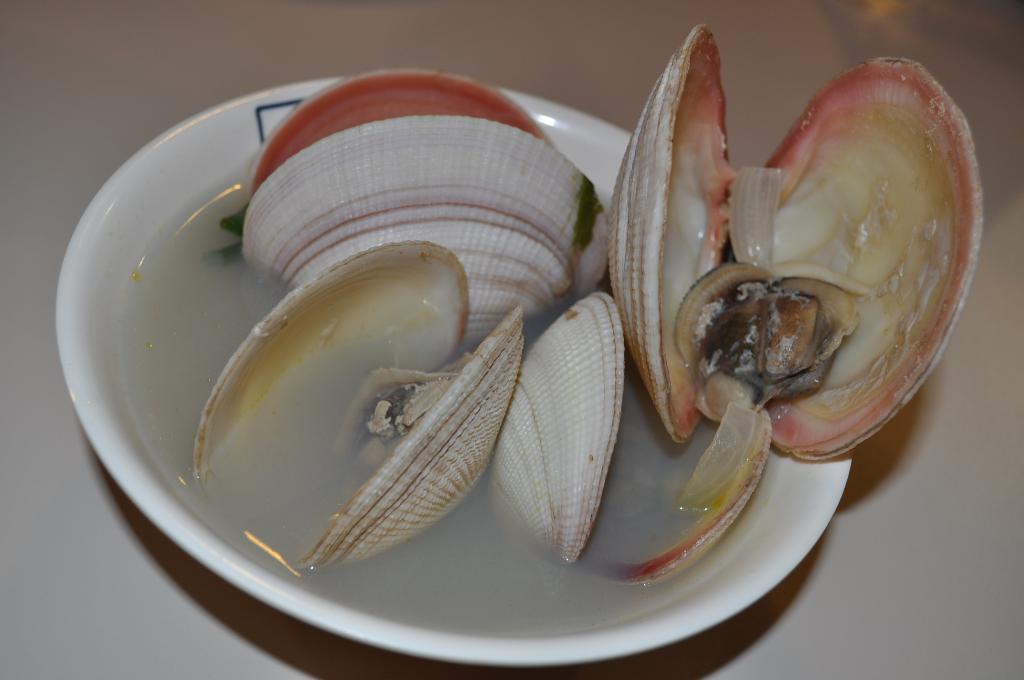Can you describe this image briefly? In the center of the image we can see one table. On the table,we can see one bowl. In the bowl,we can see water and shells. 